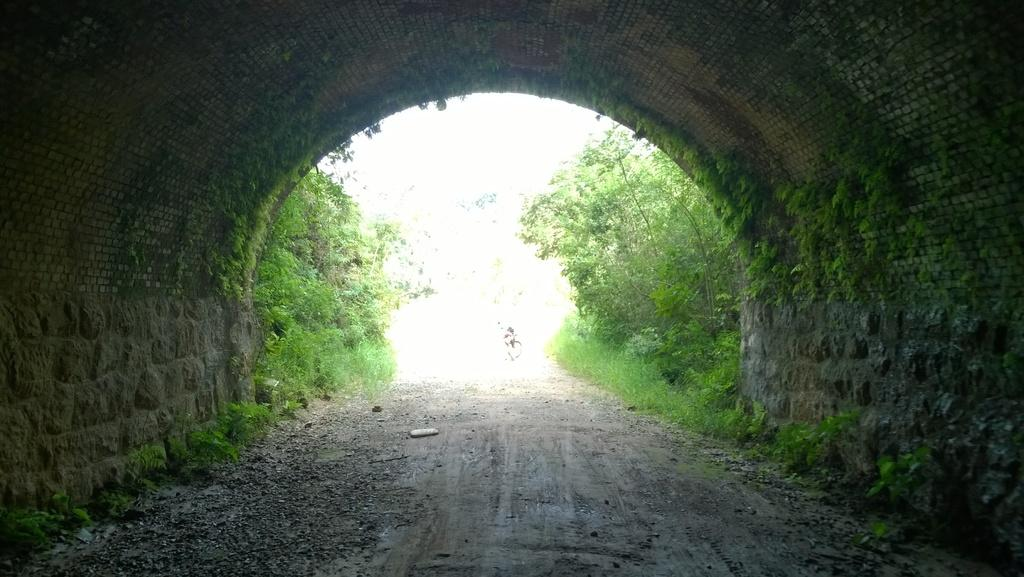What is the main subject in the center of the image? There is a tunnel in the center of the image. What can be seen in the background of the image? There are trees visible in the image. What type of ball is being played with in the image? There is no ball present in the image; it features a tunnel and trees. Can you describe the ocean visible in the image? There is no ocean present in the image; it only shows a tunnel and trees. 